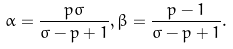<formula> <loc_0><loc_0><loc_500><loc_500>\alpha = \frac { p \sigma } { \sigma - p + 1 } , \beta = \frac { p - 1 } { \sigma - p + 1 } .</formula> 